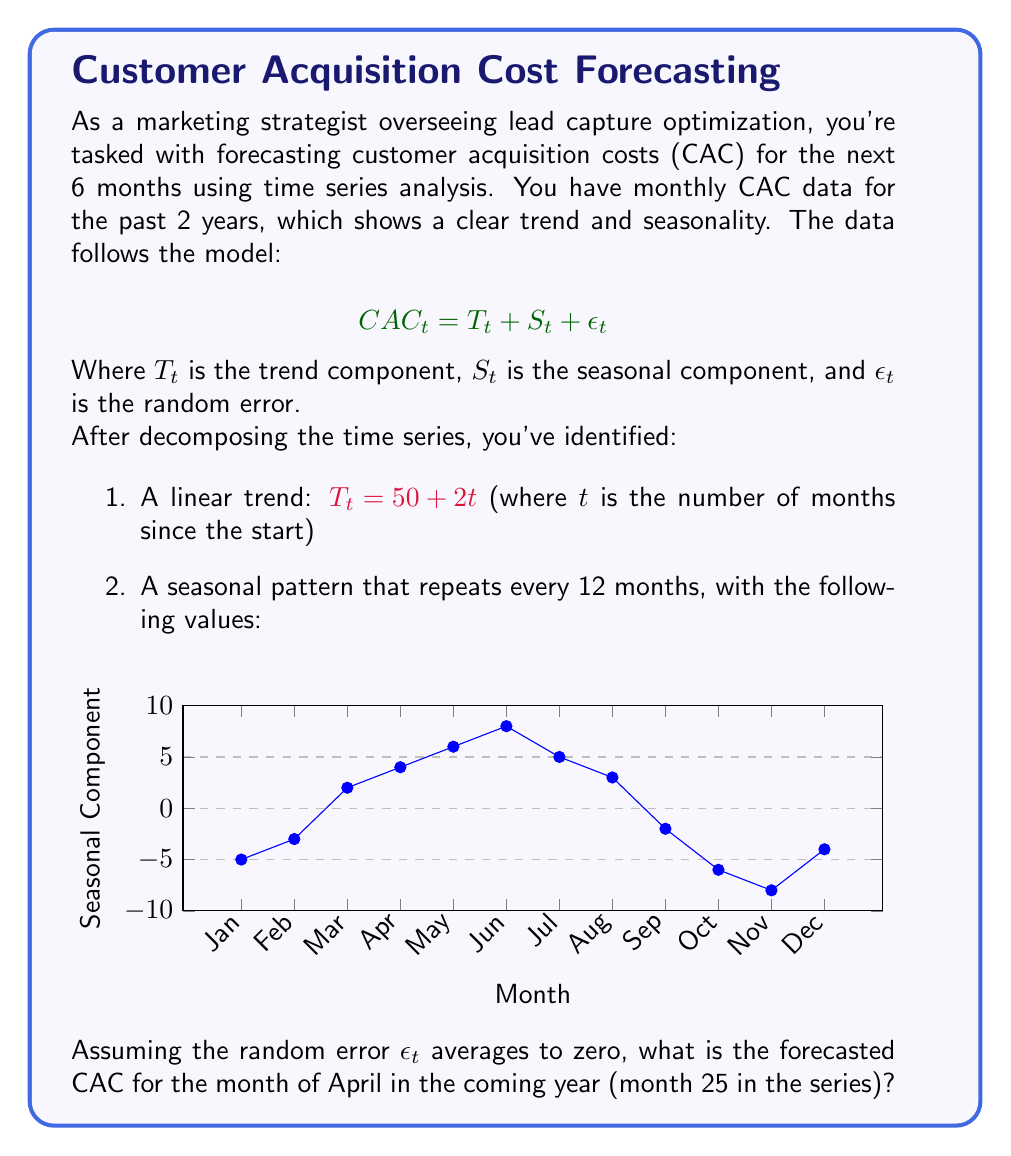Show me your answer to this math problem. To forecast the CAC for April of the coming year (month 25), we need to combine the trend and seasonal components:

1. Calculate the trend component $T_t$:
   $T_{25} = 50 + 2(25) = 50 + 50 = 100$

2. Identify the seasonal component $S_t$ for April:
   From the seasonal pattern, we can see that April has a value of 4.

3. Combine the trend and seasonal components:
   $CAC_{25} = T_{25} + S_{25} = 100 + 4 = 104$

We assume the random error $\epsilon_t$ averages to zero over time, so we don't include it in our forecast.

Therefore, the forecasted CAC for April of the coming year (month 25) is $104.
Answer: $104 